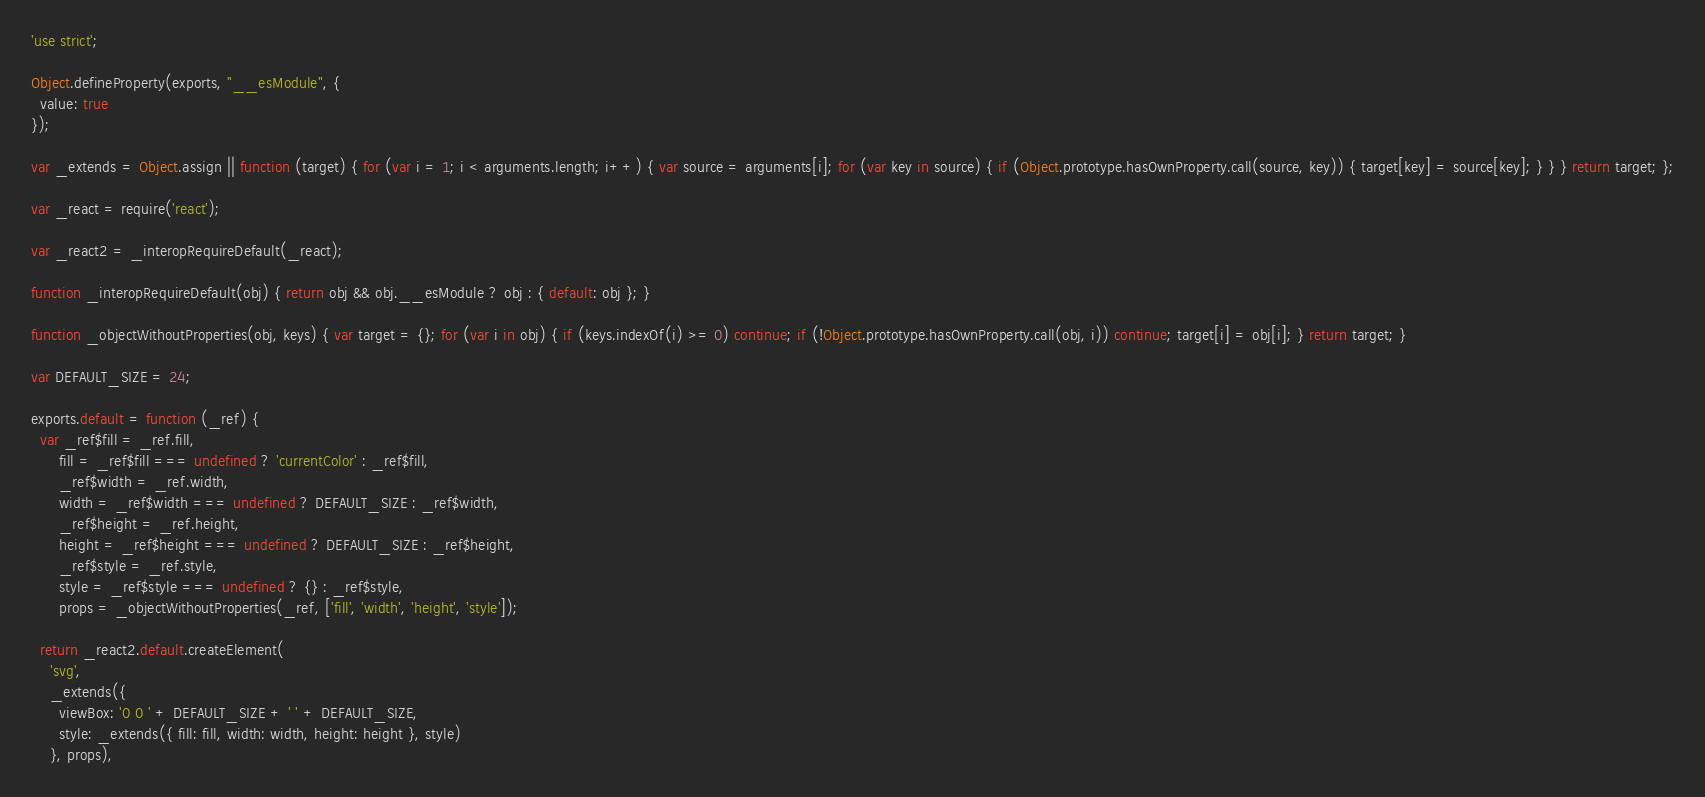Convert code to text. <code><loc_0><loc_0><loc_500><loc_500><_JavaScript_>'use strict';

Object.defineProperty(exports, "__esModule", {
  value: true
});

var _extends = Object.assign || function (target) { for (var i = 1; i < arguments.length; i++) { var source = arguments[i]; for (var key in source) { if (Object.prototype.hasOwnProperty.call(source, key)) { target[key] = source[key]; } } } return target; };

var _react = require('react');

var _react2 = _interopRequireDefault(_react);

function _interopRequireDefault(obj) { return obj && obj.__esModule ? obj : { default: obj }; }

function _objectWithoutProperties(obj, keys) { var target = {}; for (var i in obj) { if (keys.indexOf(i) >= 0) continue; if (!Object.prototype.hasOwnProperty.call(obj, i)) continue; target[i] = obj[i]; } return target; }

var DEFAULT_SIZE = 24;

exports.default = function (_ref) {
  var _ref$fill = _ref.fill,
      fill = _ref$fill === undefined ? 'currentColor' : _ref$fill,
      _ref$width = _ref.width,
      width = _ref$width === undefined ? DEFAULT_SIZE : _ref$width,
      _ref$height = _ref.height,
      height = _ref$height === undefined ? DEFAULT_SIZE : _ref$height,
      _ref$style = _ref.style,
      style = _ref$style === undefined ? {} : _ref$style,
      props = _objectWithoutProperties(_ref, ['fill', 'width', 'height', 'style']);

  return _react2.default.createElement(
    'svg',
    _extends({
      viewBox: '0 0 ' + DEFAULT_SIZE + ' ' + DEFAULT_SIZE,
      style: _extends({ fill: fill, width: width, height: height }, style)
    }, props),</code> 